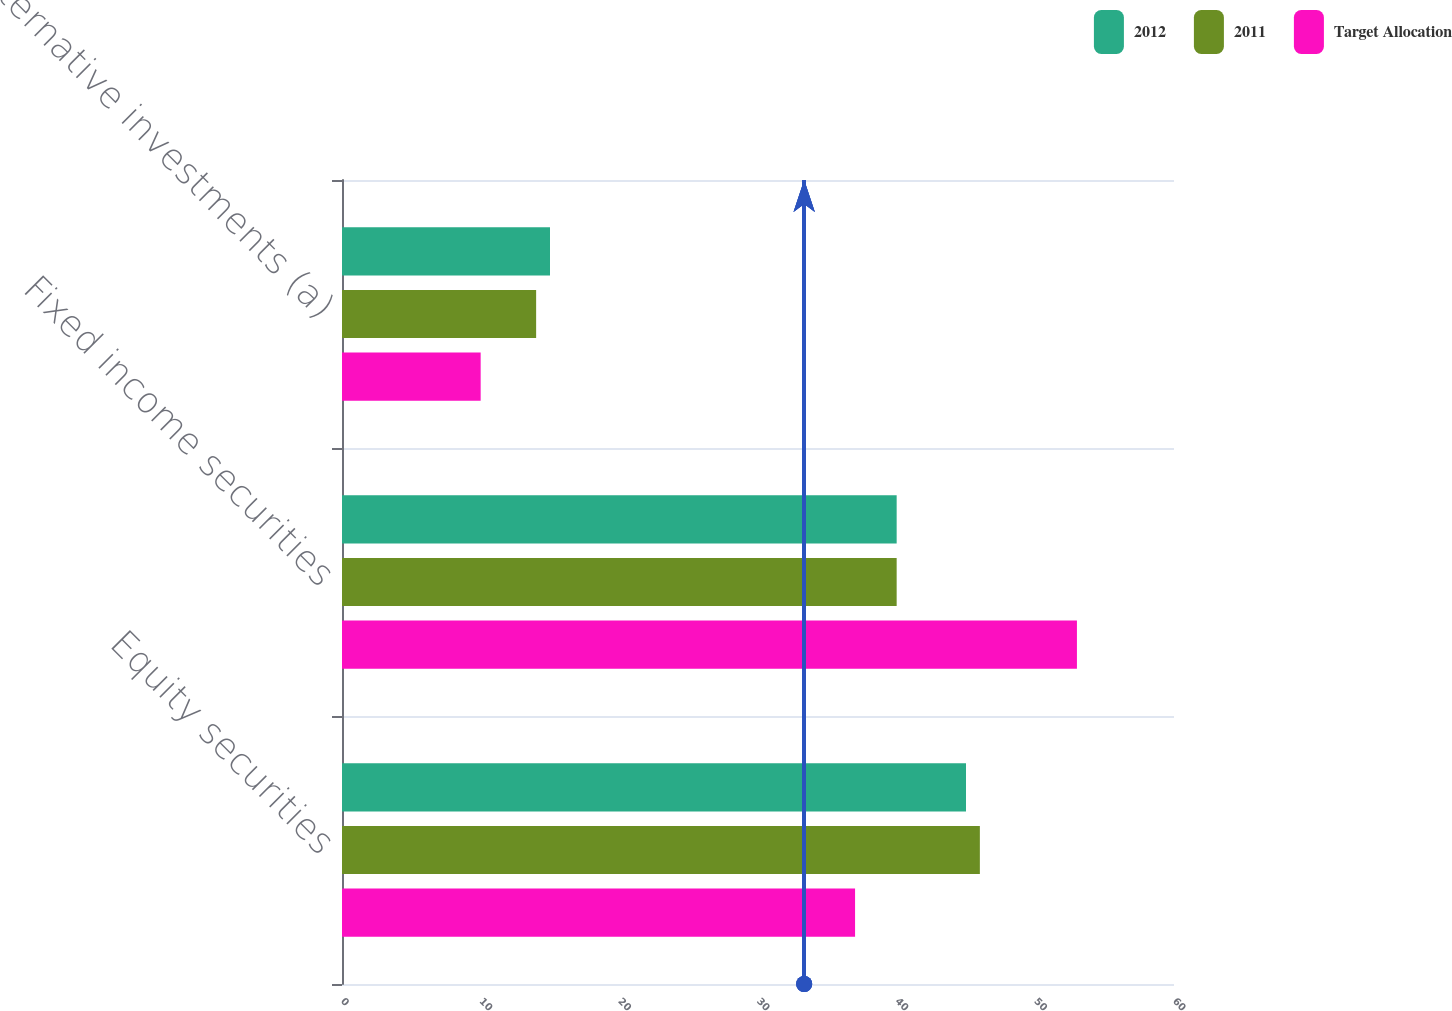Convert chart to OTSL. <chart><loc_0><loc_0><loc_500><loc_500><stacked_bar_chart><ecel><fcel>Equity securities<fcel>Fixed income securities<fcel>Alternative investments (a)<nl><fcel>2012<fcel>45<fcel>40<fcel>15<nl><fcel>2011<fcel>46<fcel>40<fcel>14<nl><fcel>Target Allocation<fcel>37<fcel>53<fcel>10<nl></chart> 